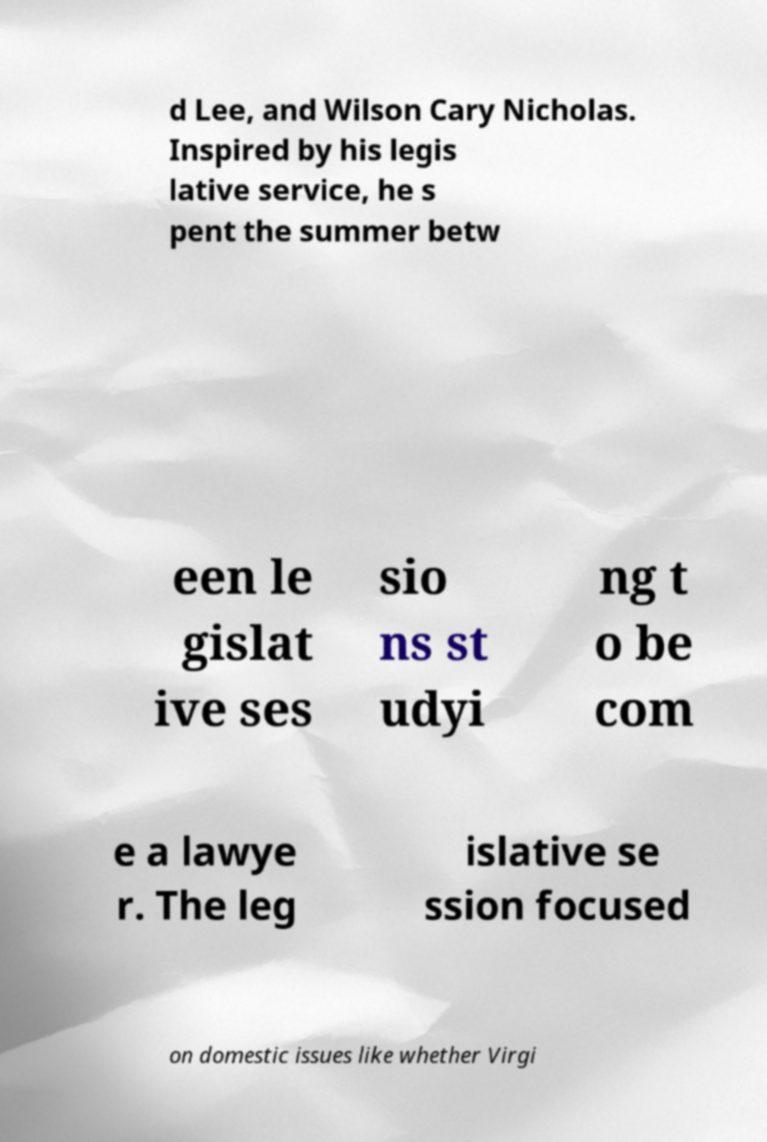Please read and relay the text visible in this image. What does it say? d Lee, and Wilson Cary Nicholas. Inspired by his legis lative service, he s pent the summer betw een le gislat ive ses sio ns st udyi ng t o be com e a lawye r. The leg islative se ssion focused on domestic issues like whether Virgi 